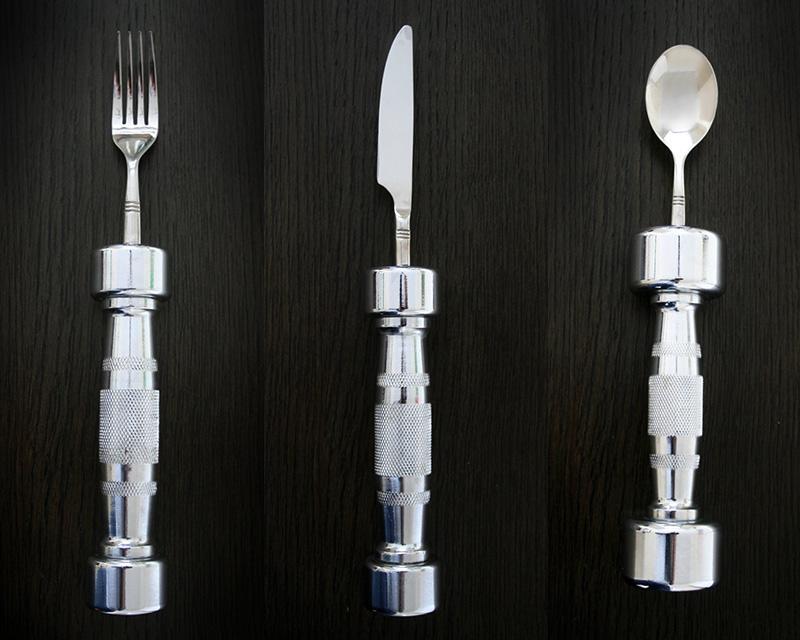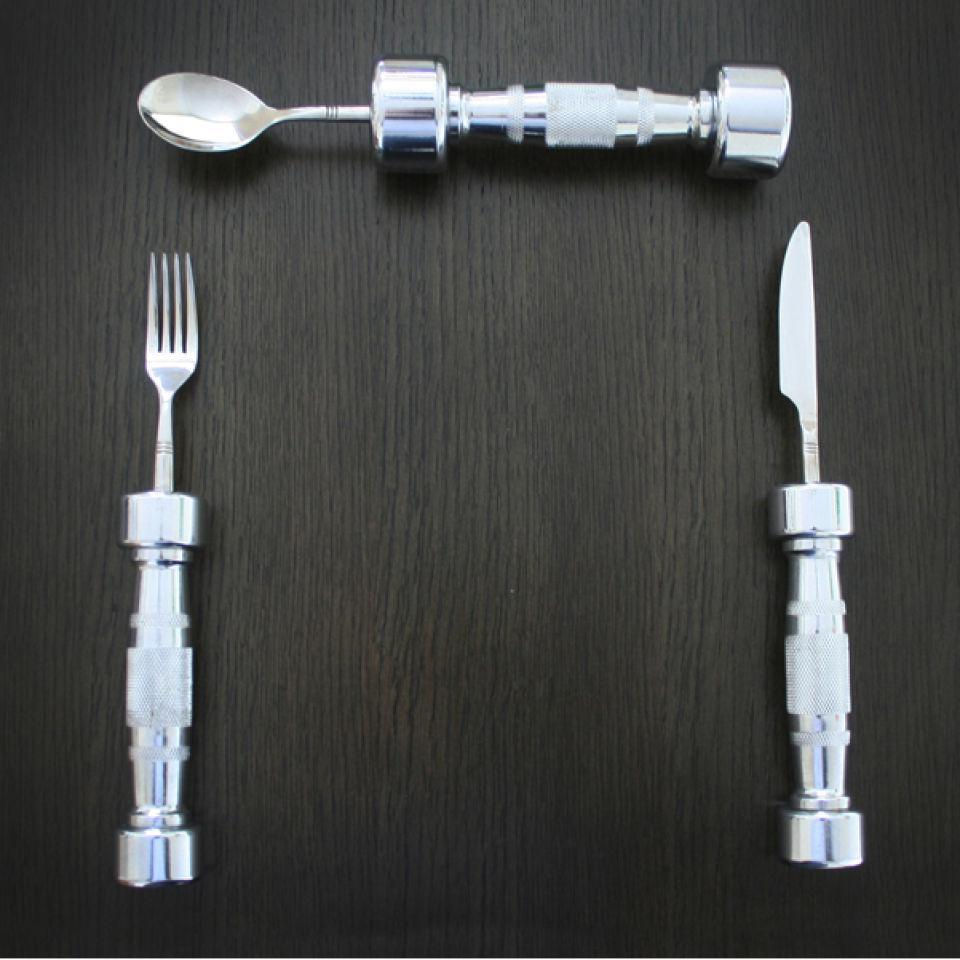The first image is the image on the left, the second image is the image on the right. For the images displayed, is the sentence "There is a knife, fork, and spoon in the image on the right." factually correct? Answer yes or no. Yes. 